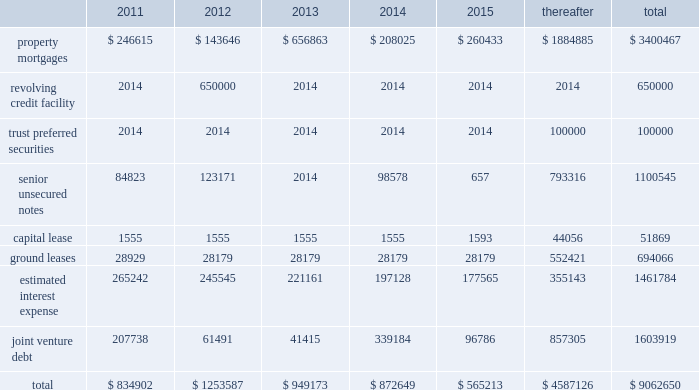Off-balance-sheet arrangements we have a number of off-balance-sheet investments , including joint ven- tures and debt and preferred equity investments .
These investments all have varying ownership structures .
Substantially all of our joint venture arrangements are accounted for under the equity method of accounting as we have the ability to exercise significant influence , but not control over the operating and financial decisions of these joint venture arrange- ments .
Our off-balance-sheet arrangements are discussed in note a0 5 , 201cdebt and preferred equity investments 201d and note a0 6 , 201cinvestments in unconsolidated joint ventures 201d in the accompanying consolidated finan- cial statements .
Additional information about the debt of our unconsoli- dated joint ventures is included in 201ccontractual obligations 201d below .
Capital expenditures we estimate that , for the year ending december a031 , 2011 , we will incur approximately $ 120.5 a0 million of capital expenditures , which are net of loan reserves ( including tenant improvements and leasing commis- sions ) , on existing wholly-owned properties , and that our share of capital expenditures at our joint venture properties , net of loan reserves , will be approximately $ 23.4 a0million .
We expect to fund these capital expen- ditures with operating cash flow , additional property level mortgage financings and cash on hand .
Future property acquisitions may require substantial capital investments for refurbishment and leasing costs .
We expect that these financing requirements will be met in a similar fashion .
We believe that we will have sufficient resources to satisfy our capital needs during the next 12-month period .
Thereafter , we expect our capital needs will be met through a combination of cash on hand , net cash provided by operations , borrowings , potential asset sales or addi- tional equity or debt issuances .
Above provides that , except to enable us to continue to qualify as a reit for federal income tax purposes , we will not during any four consecu- tive fiscal quarters make distributions with respect to common stock or other equity interests in an aggregate amount in excess of 95% ( 95 % ) of funds from operations for such period , subject to certain other adjustments .
As of december a0 31 , 2010 and 2009 , we were in compliance with all such covenants .
Market rate risk we are exposed to changes in interest rates primarily from our floating rate borrowing arrangements .
We use interest rate derivative instruments to manage exposure to interest rate changes .
A hypothetical 100 basis point increase in interest rates along the entire interest rate curve for 2010 and 2009 , would increase our annual interest cost by approximately $ 11.0 a0mil- lion and $ 15.2 a0million and would increase our share of joint venture annual interest cost by approximately $ 6.7 a0million and $ 6.4 a0million , respectively .
We recognize all derivatives on the balance sheet at fair value .
Derivatives that are not hedges must be adjusted to fair value through income .
If a derivative is a hedge , depending on the nature of the hedge , changes in the fair value of the derivative will either be offset against the change in fair value of the hedged asset , liability , or firm commitment through earnings , or recognized in other comprehensive income until the hedged item is recognized in earnings .
The ineffective portion of a deriva- tive 2019s change in fair value is recognized immediately in earnings .
Approximately $ 4.1 a0billion of our long-term debt bore interest at fixed rates , and therefore the fair value of these instruments is affected by changes in the market interest rates .
The interest rate on our variable rate debt and joint venture debt as of december a031 , 2010 ranged from libor plus 75 basis points to libor plus 400 basis points .
Contractual obligations combined aggregate principal maturities of mortgages and other loans payable , our 2007 unsecured revolving credit facility , senior unsecured notes ( net of discount ) , trust preferred securities , our share of joint venture debt , including as-of-right extension options , estimated interest expense ( based on weighted average interest rates for the quarter ) , and our obligations under our capital and ground leases , as of december a031 , 2010 , are as follows ( in thousands ) : .
48 sl green realty corp .
2010 annual report management 2019s discussion and analysis of financial condition and results of operations .
What percentage of 2013 obligations was the 2013 capital lease obligation? 
Computations: (1555 / 949173)
Answer: 0.00164. 